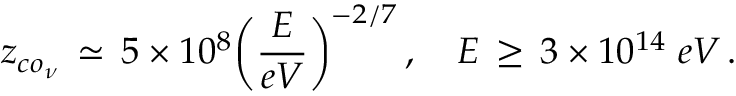Convert formula to latex. <formula><loc_0><loc_0><loc_500><loc_500>z _ { c o _ { \nu } } \, \simeq \, 5 \times 1 0 ^ { 8 } \left ( \frac { E } { e V } \right ) ^ { - 2 / 7 } \, , \quad E \, \geq \, 3 \times 1 0 ^ { 1 4 } \, e V \, .</formula> 